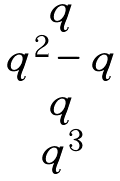<formula> <loc_0><loc_0><loc_500><loc_500>\begin{matrix} q \\ q ^ { 2 } - q \\ q \\ q ^ { 3 } \end{matrix}</formula> 